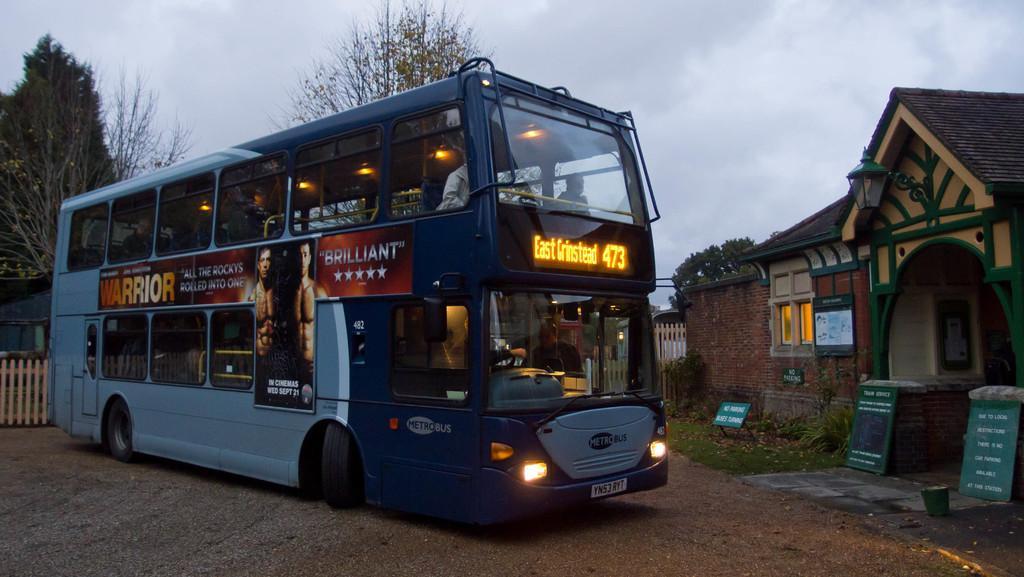In one or two sentences, can you explain what this image depicts? In this picture we can see a Double Decker Bus parked on the path and on the right side of the bus there is a house, boards, pot, light and plants. Behind the bus there is a wooden fence, shed, trees and a sky. 